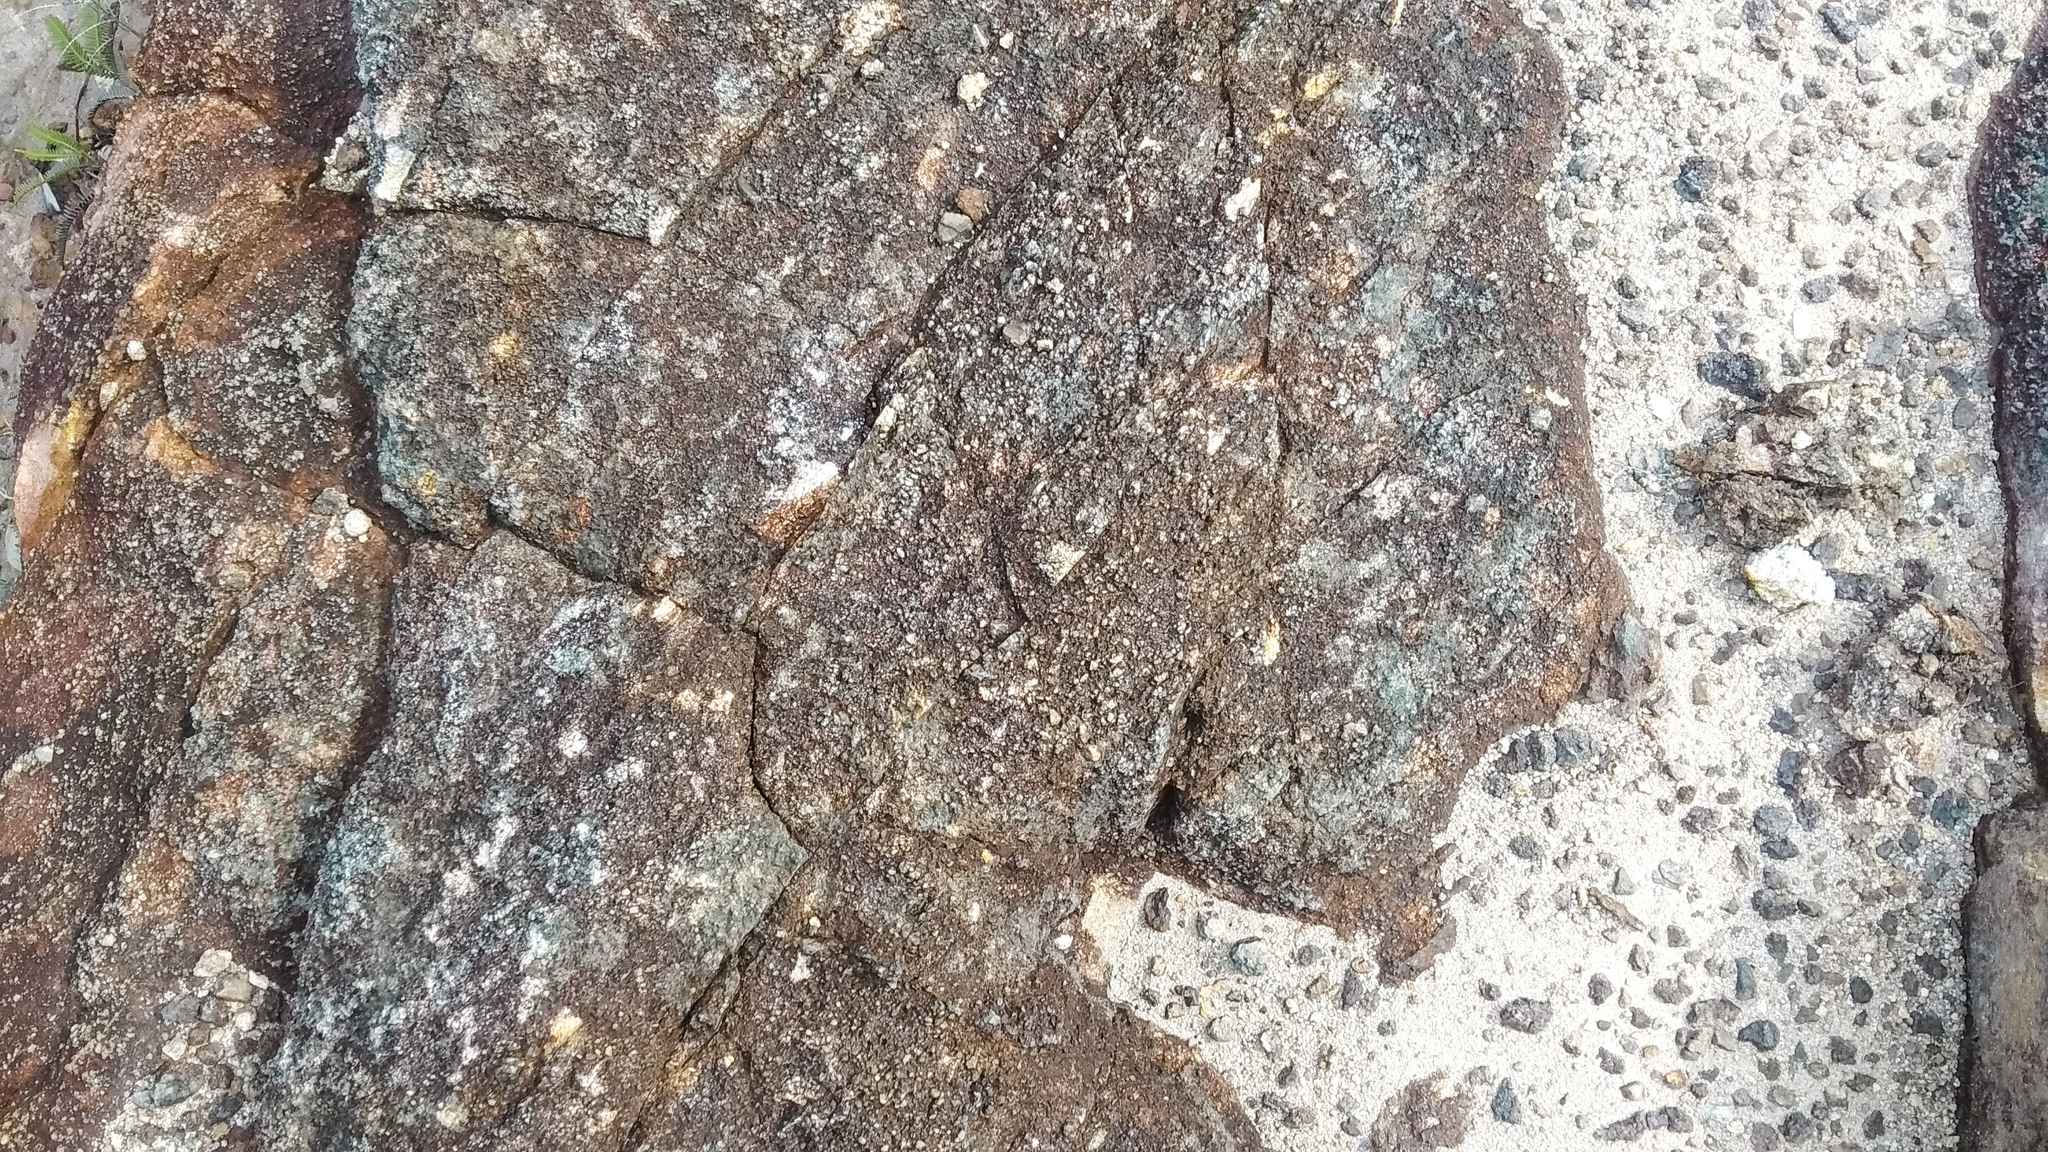Describe the texture of the stones. The texture of the stones is rugged and uneven, with various cracks and crevices giving it a coarse feel. The surface appears rough to the touch, with some areas covered in patches of moss and lichen, lending a slightly softer, more organic texture. Tiny grains and pebbles embedded in the stone add to the gritty, tactile quality of the surface. How might these stones have been used historically? Historically, stones like these could have been used in the construction of fortresses, temples, or ancient roads. Their durability and resistance to weathering make them ideal for such purposes. They might also have been utilized in boundary markers or as part of defensive walls, standing testament to the engineering prowess of ancient civilizations. Can you create a story involving these stones in a mythical context? In a forgotten corner of the world, where the forest meets the mountain, lies an ancient stone pathway believed to be the work of the gods. Legend says that these stones, now covered in moss and lichen, were once imbued with magical powers. The stones were laid by divine hands to guide heroes on their quest to find the Heart of the Forest, a legendary gem said to hold the power to restore life and fertility to the land. Over centuries, the pathway has witnessed countless tales of bravery and sacrifice, its stones absorbing the essence of each hero's spirit, glowing faintly on moonlit nights, whispering ancient secrets to those who dare to journey along its forgotten trail. Imagine a day in the life of a small creature living on this stone surface. As the sun breaks over the horizon, tiny insects and small creatures like beetles, spiders, and even the occasional lizard begin their day on the stone's surface. A beetle busily explores the nooks and crannies, searching for food, while a spider weaves its web in a shadowy crevice. As the day progresses, the stone warms up under the afternoon sun, making it a perfect basking spot for a lizard. The interplay of light and shadow across the uneven surface creates a dynamic habitat, offering shelter and sustenance to these tiny inhabitants. As dusk falls, the creatures retreat to the safety of cracks and under stones, while the nocturnal visitors like moths and night beetles come alive, thriving in this micro ecosystem. 